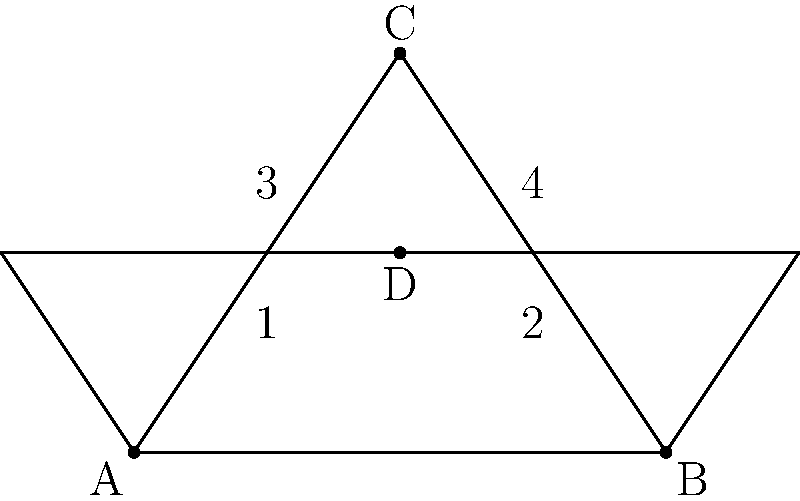In the diagram, line AB is intersected by a transversal line. Point C lies above this transversal. If angle 1 measures 50°, what is the measure of angle 4? Let's approach this step-by-step:

1) First, recall that when a transversal intersects two lines, corresponding angles are congruent. This means that angle 1 and angle 3 are equal, and angle 2 and angle 4 are equal.

2) We're given that angle 1 is 50°. Therefore, angle 3 is also 50°.

3) In a straight line, adjacent angles form a linear pair and sum to 180°. So, angle 1 and angle 2 sum to 180°:

   $50° + \text{angle 2} = 180°$
   $\text{angle 2} = 180° - 50° = 130°$

4) Since angle 2 and angle 4 are corresponding angles, they are equal. Therefore, angle 4 is also 130°.

Thus, we can conclude that the measure of angle 4 is 130°.
Answer: 130° 